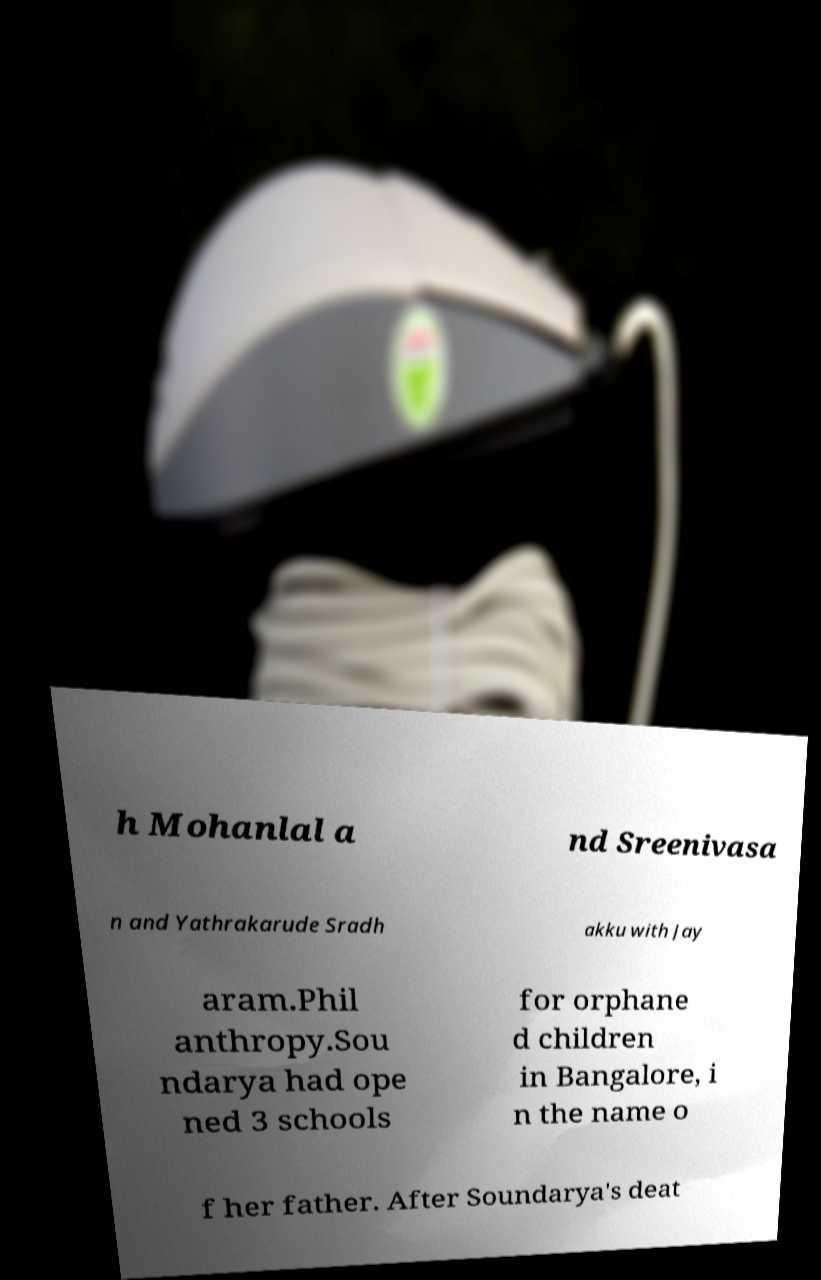Can you read and provide the text displayed in the image?This photo seems to have some interesting text. Can you extract and type it out for me? h Mohanlal a nd Sreenivasa n and Yathrakarude Sradh akku with Jay aram.Phil anthropy.Sou ndarya had ope ned 3 schools for orphane d children in Bangalore, i n the name o f her father. After Soundarya's deat 